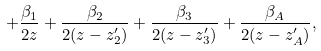<formula> <loc_0><loc_0><loc_500><loc_500>+ \frac { \beta _ { 1 } } { 2 z } + \frac { \beta _ { 2 } } { 2 ( z - z ^ { \prime } _ { 2 } ) } + \frac { \beta _ { 3 } } { 2 ( z - z ^ { \prime } _ { 3 } ) } + \frac { \beta _ { A } } { 2 ( z - z ^ { \prime } _ { A } ) } ,</formula> 